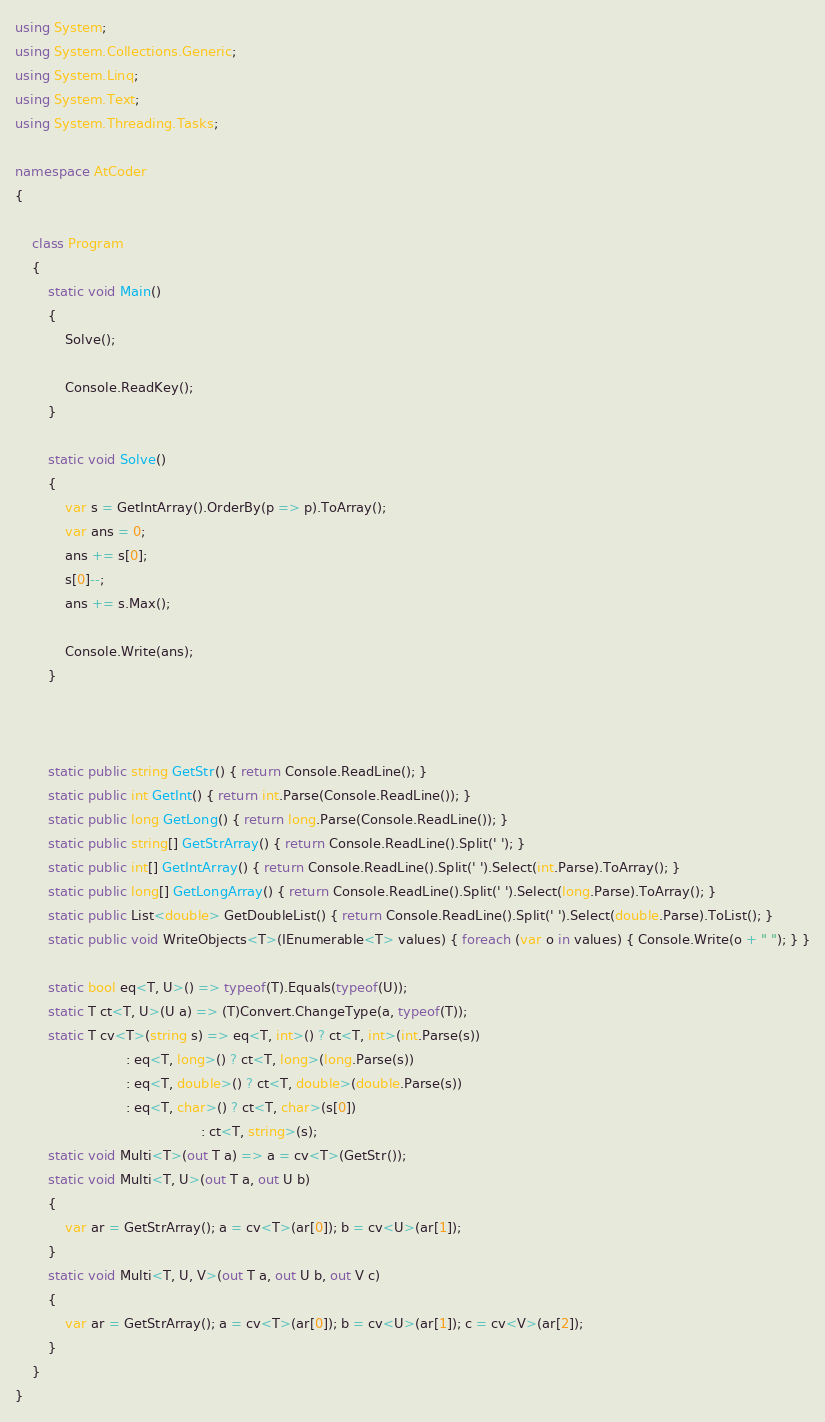<code> <loc_0><loc_0><loc_500><loc_500><_C#_>using System;
using System.Collections.Generic;
using System.Linq;
using System.Text;
using System.Threading.Tasks;

namespace AtCoder
{

    class Program
    {
        static void Main()
        {
            Solve();

            Console.ReadKey();
        }

        static void Solve()
        {
            var s = GetIntArray().OrderBy(p => p).ToArray();
            var ans = 0;
            ans += s[0];
            s[0]--;
            ans += s.Max();

            Console.Write(ans);
        }



        static public string GetStr() { return Console.ReadLine(); }
        static public int GetInt() { return int.Parse(Console.ReadLine()); }
        static public long GetLong() { return long.Parse(Console.ReadLine()); }
        static public string[] GetStrArray() { return Console.ReadLine().Split(' '); }
        static public int[] GetIntArray() { return Console.ReadLine().Split(' ').Select(int.Parse).ToArray(); }
        static public long[] GetLongArray() { return Console.ReadLine().Split(' ').Select(long.Parse).ToArray(); }
        static public List<double> GetDoubleList() { return Console.ReadLine().Split(' ').Select(double.Parse).ToList(); }
        static public void WriteObjects<T>(IEnumerable<T> values) { foreach (var o in values) { Console.Write(o + " "); } }

        static bool eq<T, U>() => typeof(T).Equals(typeof(U));
        static T ct<T, U>(U a) => (T)Convert.ChangeType(a, typeof(T));
        static T cv<T>(string s) => eq<T, int>() ? ct<T, int>(int.Parse(s))
                           : eq<T, long>() ? ct<T, long>(long.Parse(s))
                           : eq<T, double>() ? ct<T, double>(double.Parse(s))
                           : eq<T, char>() ? ct<T, char>(s[0])
                                             : ct<T, string>(s);
        static void Multi<T>(out T a) => a = cv<T>(GetStr());
        static void Multi<T, U>(out T a, out U b)
        {
            var ar = GetStrArray(); a = cv<T>(ar[0]); b = cv<U>(ar[1]);
        }
        static void Multi<T, U, V>(out T a, out U b, out V c)
        {
            var ar = GetStrArray(); a = cv<T>(ar[0]); b = cv<U>(ar[1]); c = cv<V>(ar[2]);
        }
    }
}</code> 